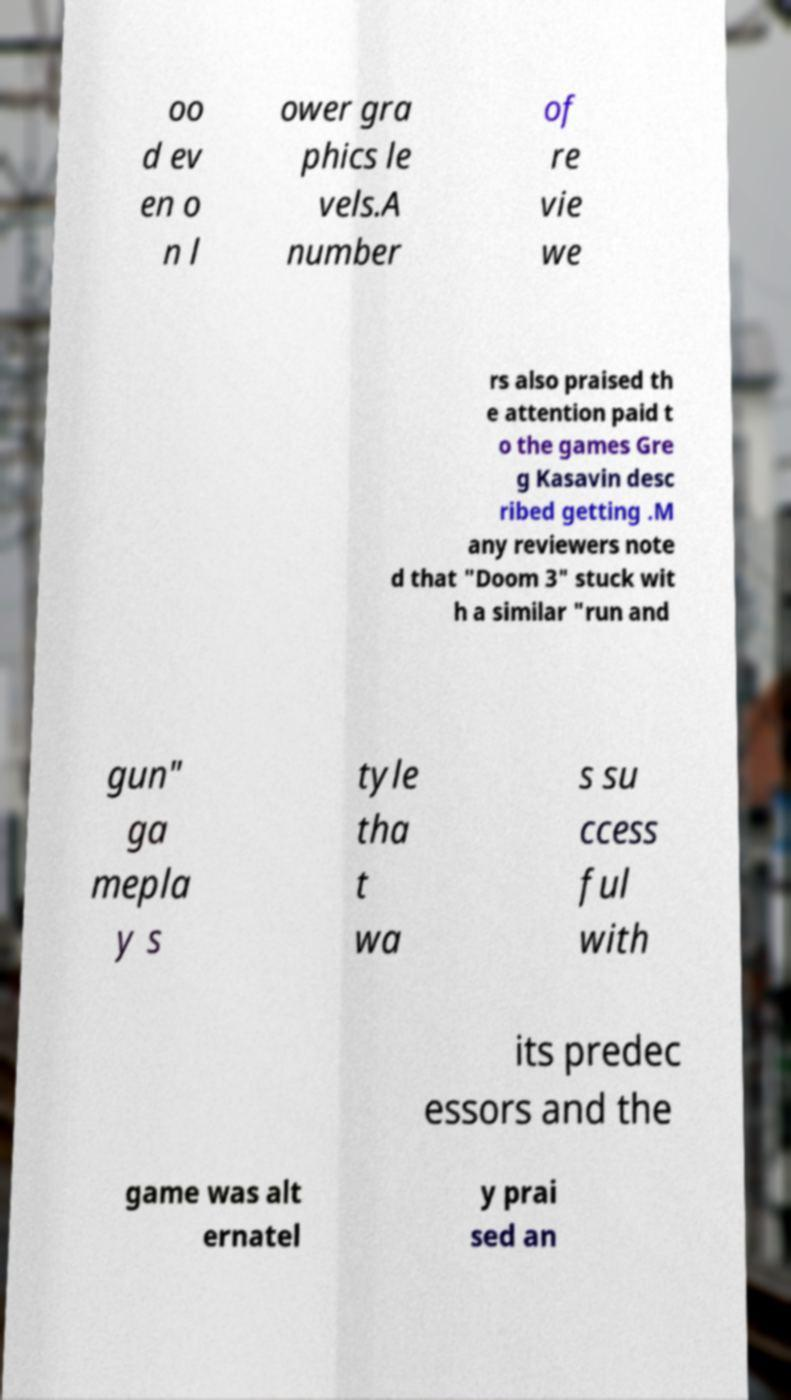For documentation purposes, I need the text within this image transcribed. Could you provide that? oo d ev en o n l ower gra phics le vels.A number of re vie we rs also praised th e attention paid t o the games Gre g Kasavin desc ribed getting .M any reviewers note d that "Doom 3" stuck wit h a similar "run and gun" ga mepla y s tyle tha t wa s su ccess ful with its predec essors and the game was alt ernatel y prai sed an 